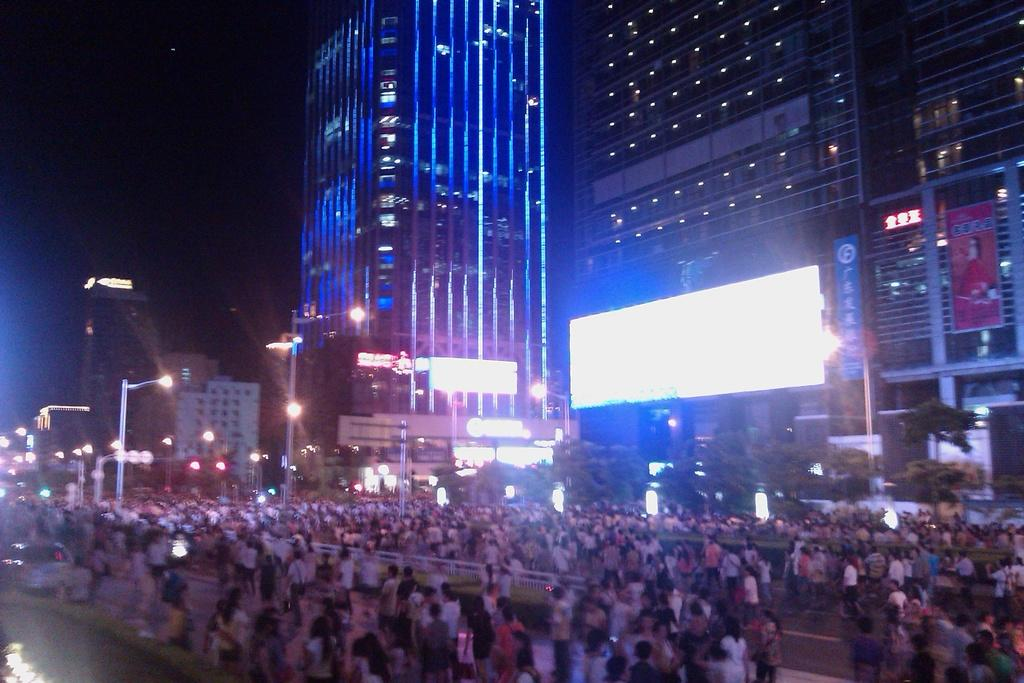What is the main subject of the image? The main subject of the image is a group of people. Where are the people located in the image? The people are on the roads in the image. What else can be seen in the image besides the people? There are poles, lights, and buildings visible in the image. How would you describe the background of the image? The background of the image is dark. What type of surprise can be seen in the image? There is no surprise present in the image. What kind of mass is visible in the image? There is no mass present in the image. 